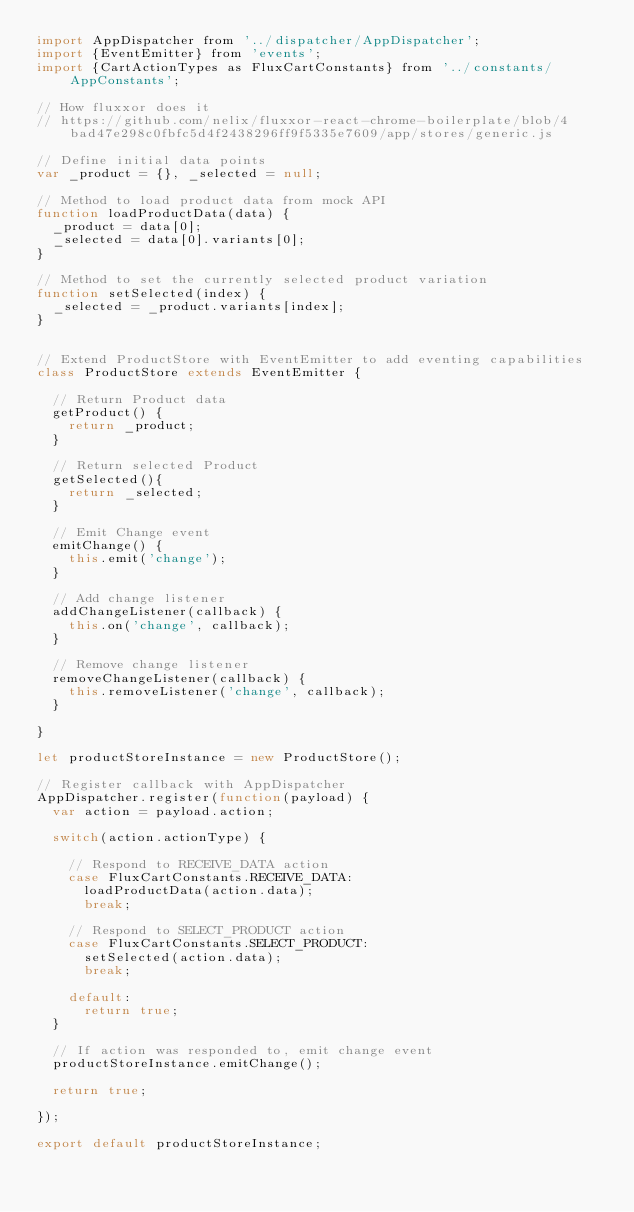<code> <loc_0><loc_0><loc_500><loc_500><_JavaScript_>import AppDispatcher from '../dispatcher/AppDispatcher';
import {EventEmitter} from 'events';
import {CartActionTypes as FluxCartConstants} from '../constants/AppConstants';

// How fluxxor does it
// https://github.com/nelix/fluxxor-react-chrome-boilerplate/blob/4bad47e298c0fbfc5d4f2438296ff9f5335e7609/app/stores/generic.js

// Define initial data points
var _product = {}, _selected = null;

// Method to load product data from mock API
function loadProductData(data) {
  _product = data[0];
  _selected = data[0].variants[0];
}

// Method to set the currently selected product variation
function setSelected(index) {
  _selected = _product.variants[index];
}


// Extend ProductStore with EventEmitter to add eventing capabilities
class ProductStore extends EventEmitter {

  // Return Product data
  getProduct() {
    return _product;
  }

  // Return selected Product
  getSelected(){
    return _selected;
  }

  // Emit Change event
  emitChange() {
    this.emit('change');
  }

  // Add change listener
  addChangeListener(callback) {
    this.on('change', callback);
  }

  // Remove change listener
  removeChangeListener(callback) {
    this.removeListener('change', callback);
  }

}

let productStoreInstance = new ProductStore();

// Register callback with AppDispatcher
AppDispatcher.register(function(payload) {
  var action = payload.action;

  switch(action.actionType) {

    // Respond to RECEIVE_DATA action
    case FluxCartConstants.RECEIVE_DATA:
      loadProductData(action.data);
      break;

    // Respond to SELECT_PRODUCT action
    case FluxCartConstants.SELECT_PRODUCT:
      setSelected(action.data);
      break;

    default:
      return true;
  }

  // If action was responded to, emit change event
  productStoreInstance.emitChange();

  return true;

});

export default productStoreInstance;

</code> 